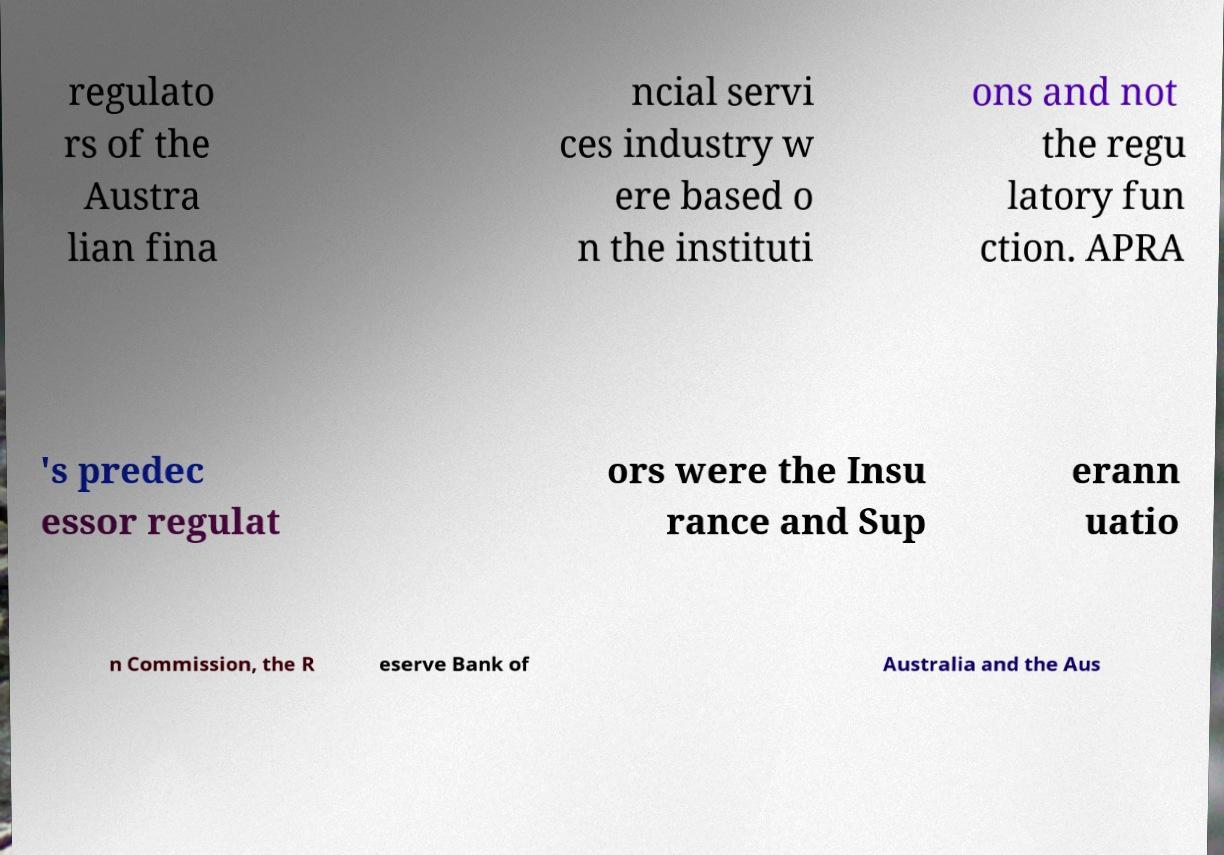Please identify and transcribe the text found in this image. regulato rs of the Austra lian fina ncial servi ces industry w ere based o n the instituti ons and not the regu latory fun ction. APRA 's predec essor regulat ors were the Insu rance and Sup erann uatio n Commission, the R eserve Bank of Australia and the Aus 